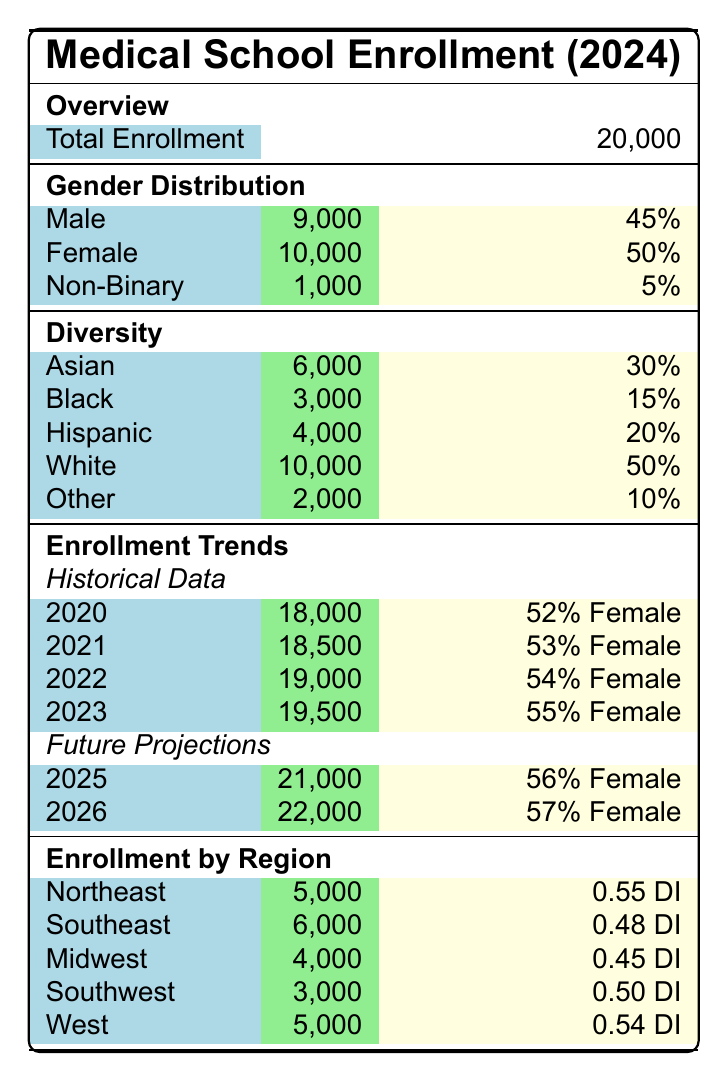What is the total enrollment for medical schools in 2024? The total enrollment figure is explicitly stated in the Overview section of the table, which shows 20,000 students for the year 2024.
Answer: 20,000 How many male students are enrolled in medical schools in 2024? The table provides the gender distribution under Overview, where it specifically mentions that there are 9,000 male students enrolled.
Answer: 9,000 What percentage of the medical school enrollment in 2024 is female? The gender distribution section indicates that out of 20,000 total students, 10,000 are female. To find the percentage, we calculate (10,000 / 20,000) * 100, which yields 50%.
Answer: 50% What is the diversity index for the Southeast region's enrollment in 2024? The Enrollment by Region section specifies that the diversity index for the Southeast is 0.48. This value is directly provided in the table.
Answer: 0.48 Which region has the highest enrollment in 2024, and how many students are enrolled there? Comparing the enrollment numbers across all regions listed in the Enrollment by Region section, the Southeast has the highest enrollment with 6,000 students.
Answer: Southeast, 6,000 Is the total enrollment for 2024 higher than the total enrollment for 2023? The historical data for 2023 shows a total enrollment of 19,500. Since 20,000 in 2024 is greater than 19,500, the answer is yes.
Answer: Yes What is the growth in the number of female students from 2020 to 2024? In 2020, the percentage of female students was 52%. The total enrollment for 2020 was 18,000, leading to 9,360 female students (52% of 18,000). In 2024, there are 10,000 female students. The growth is calculated as 10,000 - 9,360 = 640.
Answer: 640 What is the total diversity index for all the regions in 2024? To find the total diversity index for all regions, we need to add the diversity indices of each region and then divide by the number of regions. This is (0.55 + 0.48 + 0.45 + 0.50 + 0.54) / 5 = 0.504.
Answer: 0.504 What is the projected enrollment in 2026 compared to 2024? The projected enrollment in 2026 is reported as 22,000, which is 2,000 more than the enrollment in 2024 (20,000). Thus, the difference is 22,000 - 20,000 = 2,000.
Answer: 2,000 